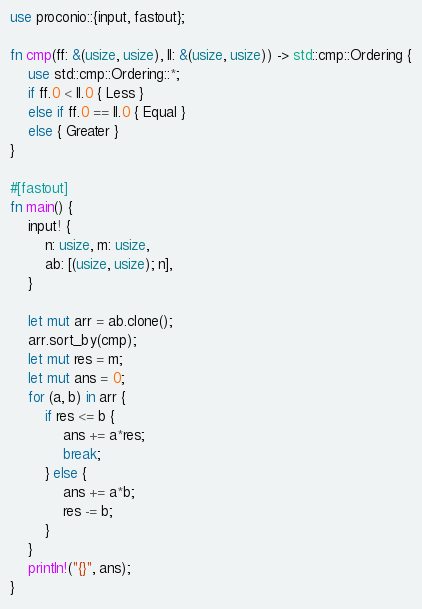<code> <loc_0><loc_0><loc_500><loc_500><_Rust_>use proconio::{input, fastout};

fn cmp(ff: &(usize, usize), ll: &(usize, usize)) -> std::cmp::Ordering {
    use std::cmp::Ordering::*;
    if ff.0 < ll.0 { Less }
    else if ff.0 == ll.0 { Equal }
    else { Greater }
}

#[fastout]
fn main() {
    input! {
        n: usize, m: usize,
        ab: [(usize, usize); n],
    }

    let mut arr = ab.clone();
    arr.sort_by(cmp);
    let mut res = m;
    let mut ans = 0;
    for (a, b) in arr {
        if res <= b {
            ans += a*res;
            break;
        } else {
            ans += a*b;
            res -= b;
        }
    }
    println!("{}", ans);
}
</code> 